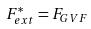Convert formula to latex. <formula><loc_0><loc_0><loc_500><loc_500>F _ { e x t } ^ { * } = F _ { G V F }</formula> 